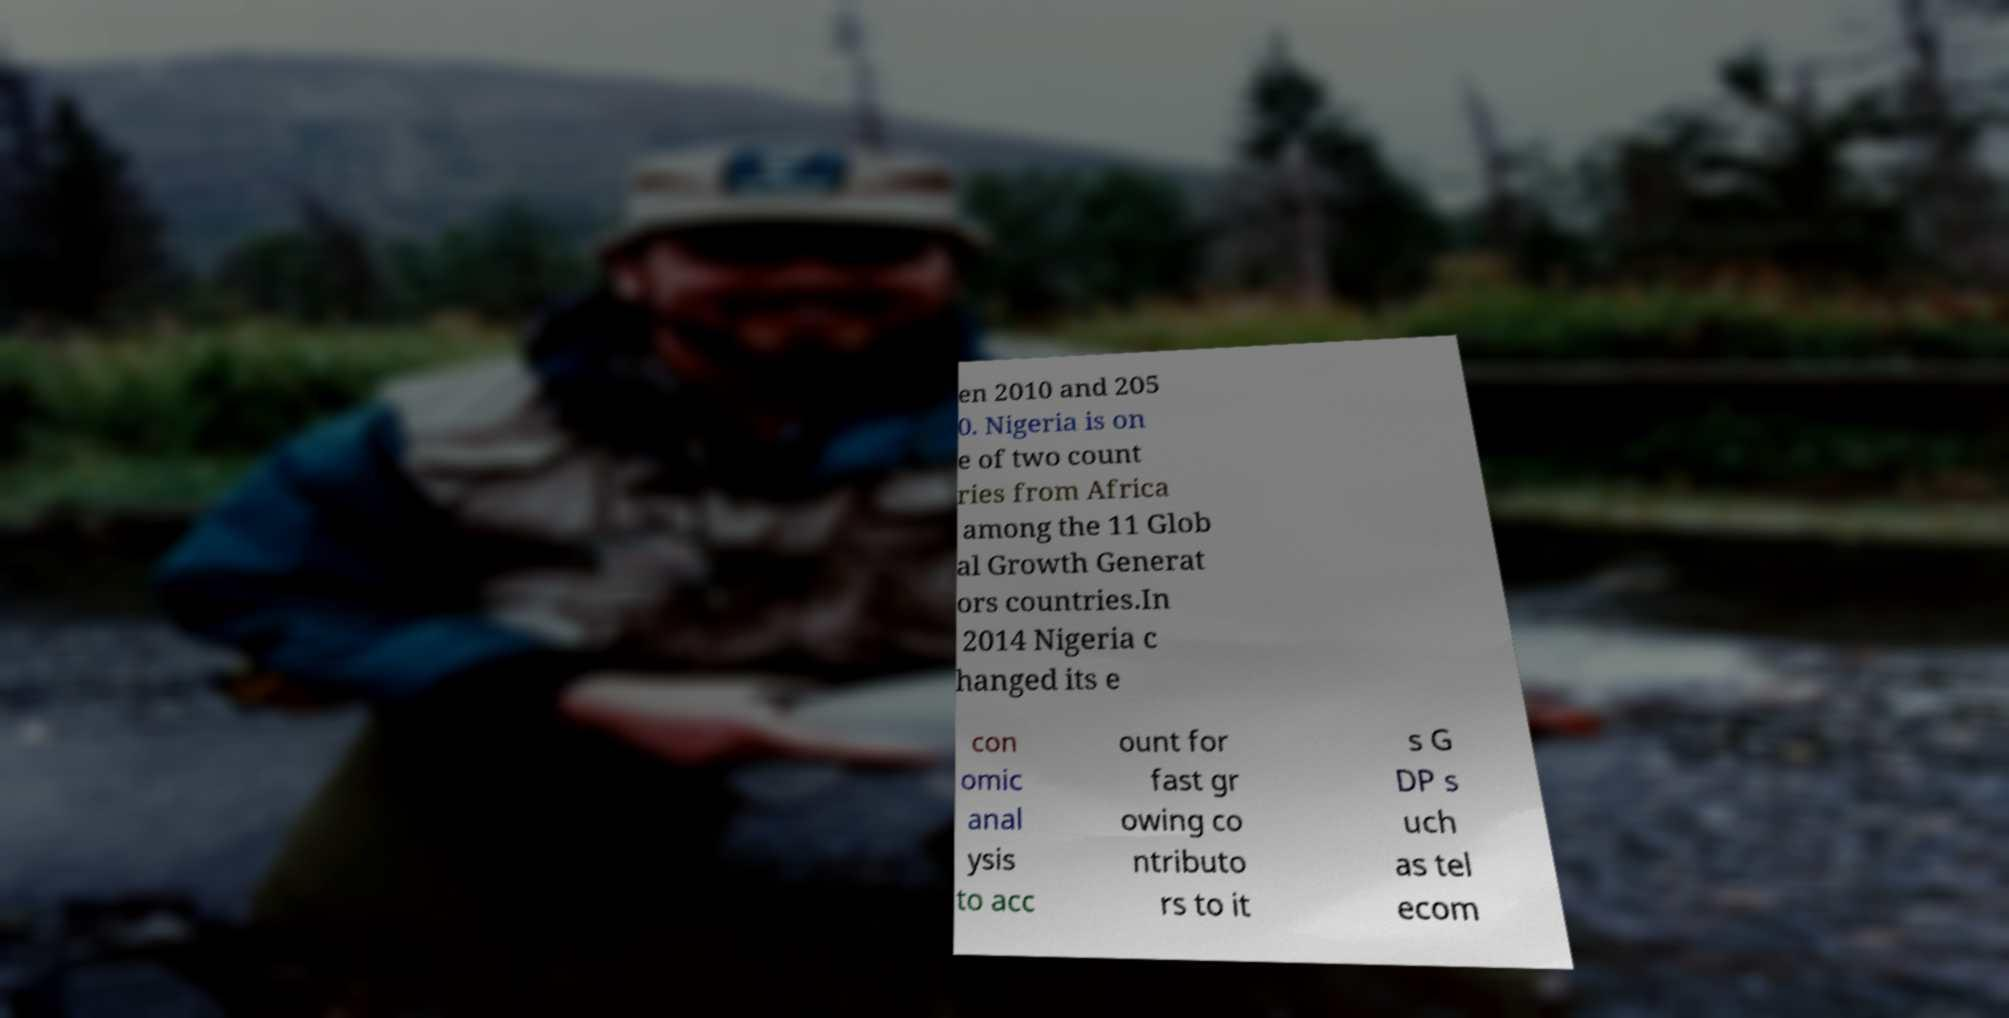Can you read and provide the text displayed in the image?This photo seems to have some interesting text. Can you extract and type it out for me? en 2010 and 205 0. Nigeria is on e of two count ries from Africa among the 11 Glob al Growth Generat ors countries.In 2014 Nigeria c hanged its e con omic anal ysis to acc ount for fast gr owing co ntributo rs to it s G DP s uch as tel ecom 